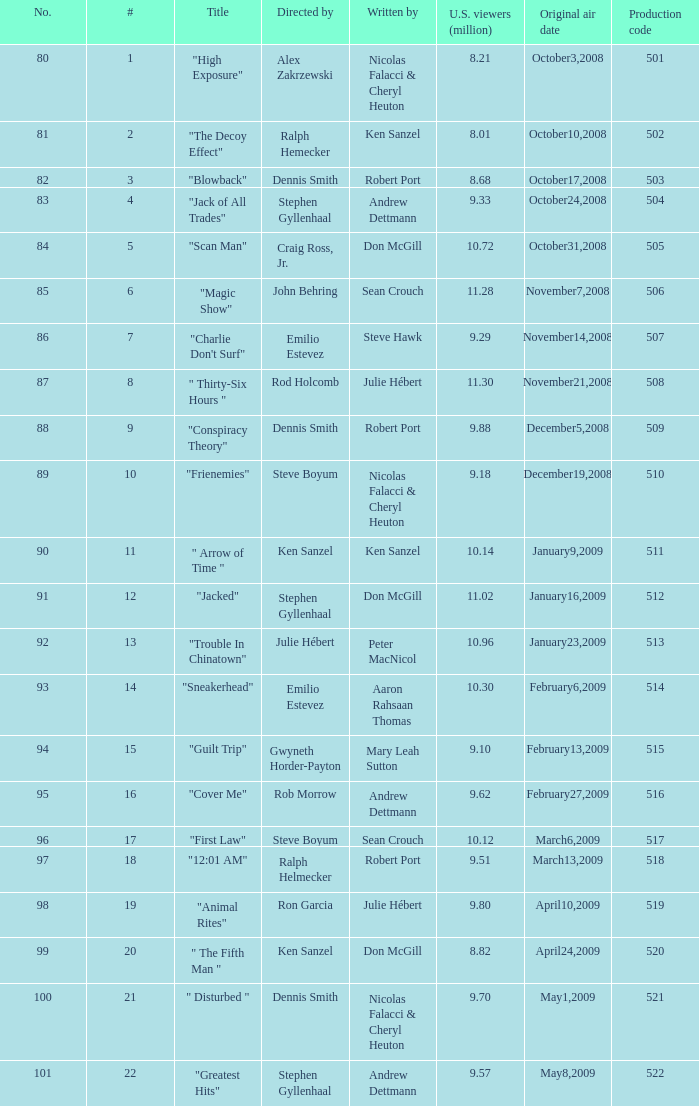Help me parse the entirety of this table. {'header': ['No.', '#', 'Title', 'Directed by', 'Written by', 'U.S. viewers (million)', 'Original air date', 'Production code'], 'rows': [['80', '1', '"High Exposure"', 'Alex Zakrzewski', 'Nicolas Falacci & Cheryl Heuton', '8.21', 'October3,2008', '501'], ['81', '2', '"The Decoy Effect"', 'Ralph Hemecker', 'Ken Sanzel', '8.01', 'October10,2008', '502'], ['82', '3', '"Blowback"', 'Dennis Smith', 'Robert Port', '8.68', 'October17,2008', '503'], ['83', '4', '"Jack of All Trades"', 'Stephen Gyllenhaal', 'Andrew Dettmann', '9.33', 'October24,2008', '504'], ['84', '5', '"Scan Man"', 'Craig Ross, Jr.', 'Don McGill', '10.72', 'October31,2008', '505'], ['85', '6', '"Magic Show"', 'John Behring', 'Sean Crouch', '11.28', 'November7,2008', '506'], ['86', '7', '"Charlie Don\'t Surf"', 'Emilio Estevez', 'Steve Hawk', '9.29', 'November14,2008', '507'], ['87', '8', '" Thirty-Six Hours "', 'Rod Holcomb', 'Julie Hébert', '11.30', 'November21,2008', '508'], ['88', '9', '"Conspiracy Theory"', 'Dennis Smith', 'Robert Port', '9.88', 'December5,2008', '509'], ['89', '10', '"Frienemies"', 'Steve Boyum', 'Nicolas Falacci & Cheryl Heuton', '9.18', 'December19,2008', '510'], ['90', '11', '" Arrow of Time "', 'Ken Sanzel', 'Ken Sanzel', '10.14', 'January9,2009', '511'], ['91', '12', '"Jacked"', 'Stephen Gyllenhaal', 'Don McGill', '11.02', 'January16,2009', '512'], ['92', '13', '"Trouble In Chinatown"', 'Julie Hébert', 'Peter MacNicol', '10.96', 'January23,2009', '513'], ['93', '14', '"Sneakerhead"', 'Emilio Estevez', 'Aaron Rahsaan Thomas', '10.30', 'February6,2009', '514'], ['94', '15', '"Guilt Trip"', 'Gwyneth Horder-Payton', 'Mary Leah Sutton', '9.10', 'February13,2009', '515'], ['95', '16', '"Cover Me"', 'Rob Morrow', 'Andrew Dettmann', '9.62', 'February27,2009', '516'], ['96', '17', '"First Law"', 'Steve Boyum', 'Sean Crouch', '10.12', 'March6,2009', '517'], ['97', '18', '"12:01 AM"', 'Ralph Helmecker', 'Robert Port', '9.51', 'March13,2009', '518'], ['98', '19', '"Animal Rites"', 'Ron Garcia', 'Julie Hébert', '9.80', 'April10,2009', '519'], ['99', '20', '" The Fifth Man "', 'Ken Sanzel', 'Don McGill', '8.82', 'April24,2009', '520'], ['100', '21', '" Disturbed "', 'Dennis Smith', 'Nicolas Falacci & Cheryl Heuton', '9.70', 'May1,2009', '521'], ['101', '22', '"Greatest Hits"', 'Stephen Gyllenhaal', 'Andrew Dettmann', '9.57', 'May8,2009', '522']]} How many times did episode 6 originally air? 1.0. 